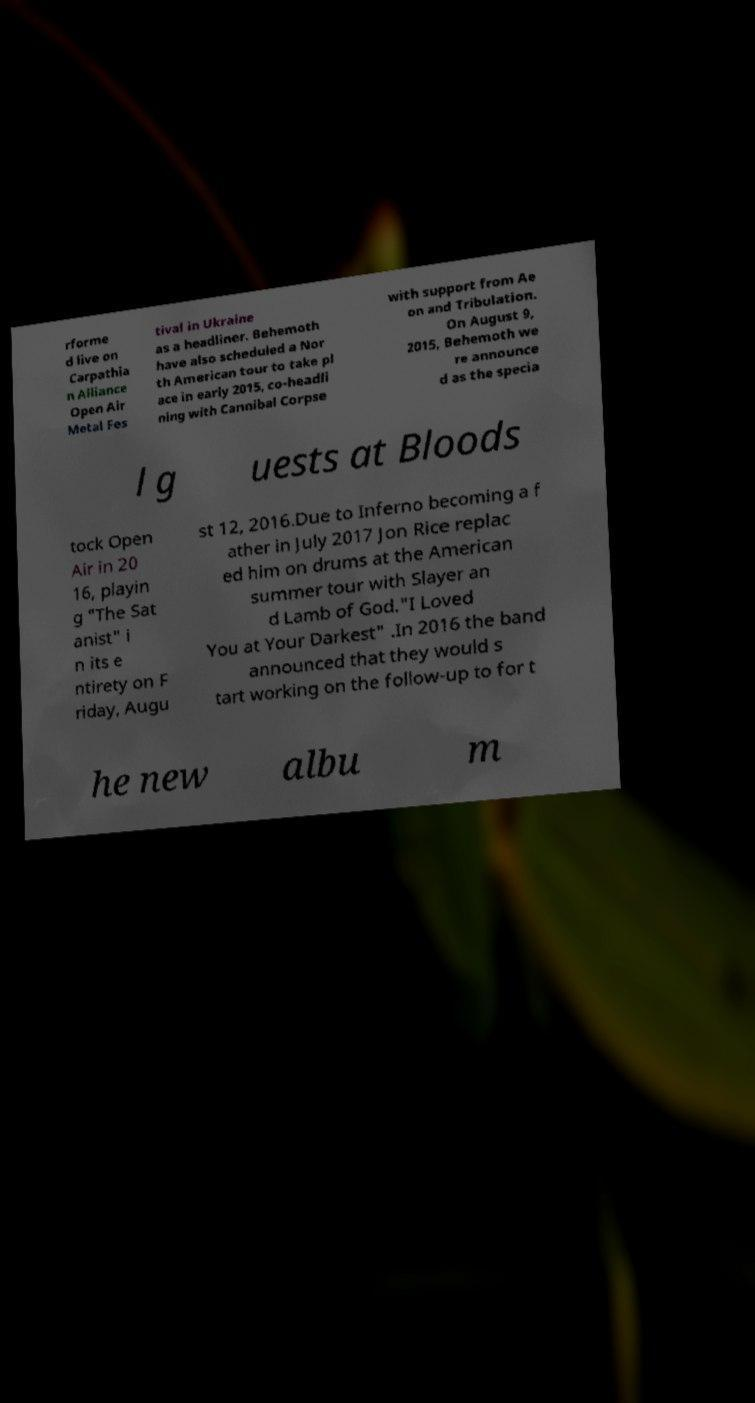Could you extract and type out the text from this image? rforme d live on Carpathia n Alliance Open Air Metal Fes tival in Ukraine as a headliner. Behemoth have also scheduled a Nor th American tour to take pl ace in early 2015, co-headli ning with Cannibal Corpse with support from Ae on and Tribulation. On August 9, 2015, Behemoth we re announce d as the specia l g uests at Bloods tock Open Air in 20 16, playin g "The Sat anist" i n its e ntirety on F riday, Augu st 12, 2016.Due to Inferno becoming a f ather in July 2017 Jon Rice replac ed him on drums at the American summer tour with Slayer an d Lamb of God."I Loved You at Your Darkest" .In 2016 the band announced that they would s tart working on the follow-up to for t he new albu m 